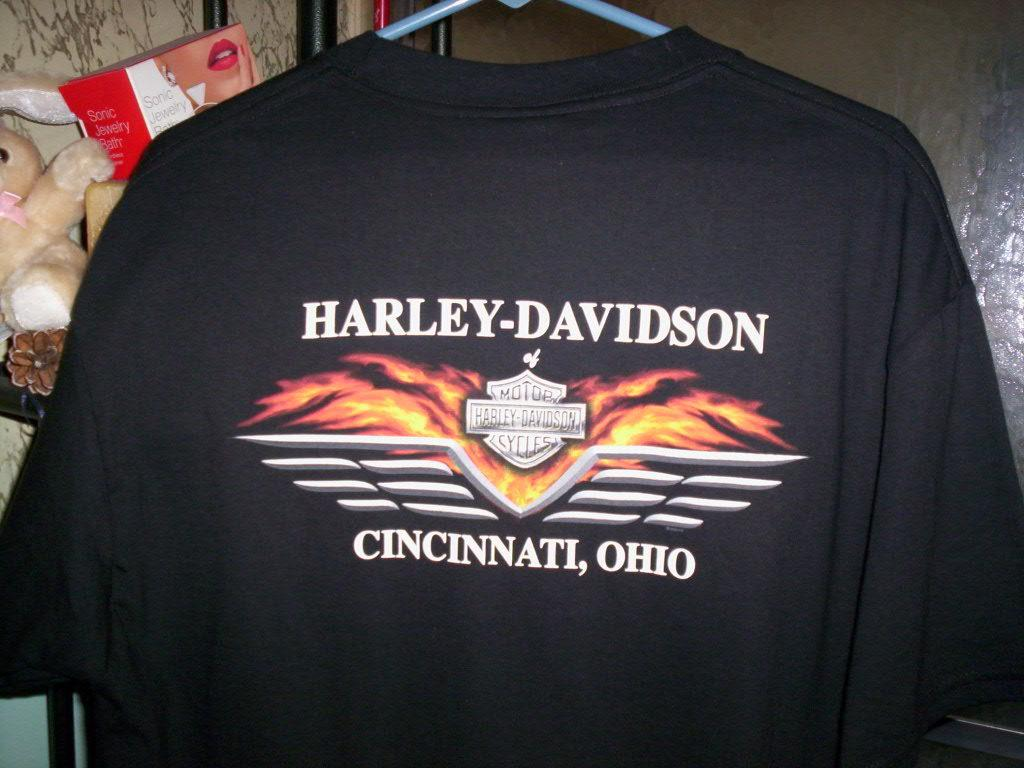Provide a one-sentence caption for the provided image. A black Harley Davidson t-shirt from Cincinnati Ohio. 